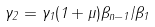Convert formula to latex. <formula><loc_0><loc_0><loc_500><loc_500>\gamma _ { 2 } = \gamma _ { 1 } ( 1 + \mu ) \beta _ { n - 1 } / \beta _ { 1 }</formula> 